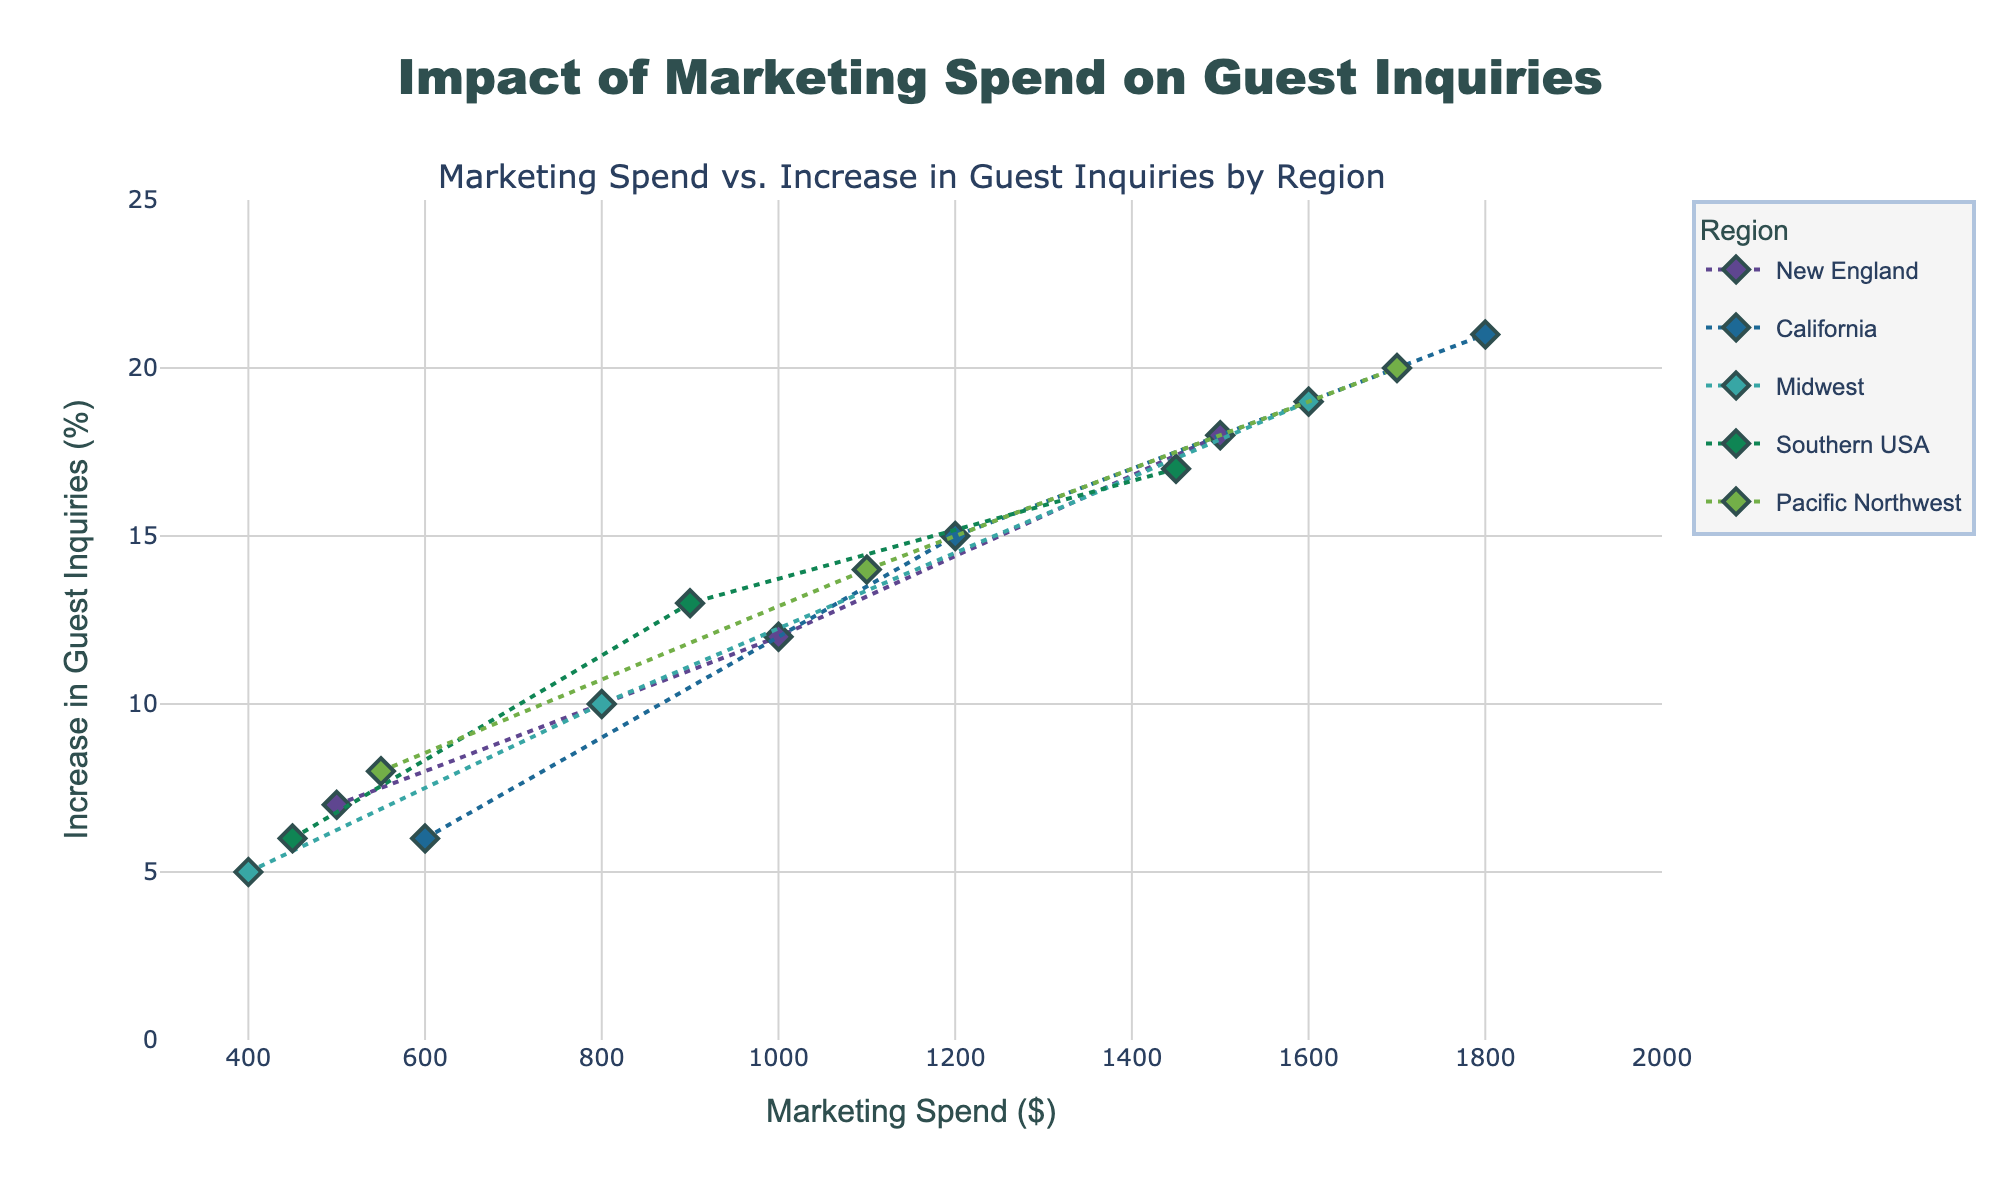How does marketing spend affect guest inquiries in the California region? By observing the scatter plot for the California region, we see that as the marketing spend increases from $600 to $1800, guest inquiries increase from 6% to 21%. There is a positive correlation between marketing spend and guest inquiries.
Answer: Positive correlation Which region shows the highest increase in guest inquiries for the same marketing spend of $1500? By comparing the data points closest to the $1500 marketing spend mark in each region, the Pacific Northwest has the highest increase in guest inquiries at around 20%.
Answer: Pacific Northwest What is the trend of marketing spend vs. increase in guest inquiries for the Midwest region? In the Midwest region, as marketing spend increases from $400 to $1600, guest inquiries increase from 5% to 19%, indicating a positive correlation.
Answer: Positive correlation Is there any region where increase in guest inquiries is less than 10% for the highest marketing spend? By examining the data points, all regions show more than a 10% increase in guest inquiries for their highest marketing spend.
Answer: No Compare the average increase in guest inquiries for New England and Midwest regions. To find the average increase, sum the respective % increases and divide by the number of data points. For New England: (7 + 12+ 18)/3 = 12.33%. For Midwest: (5 + 10 + 19)/3 = 11.33%. New England has a slightly higher average.
Answer: New England Which region has the steepest increase in guest inquiries as a function of marketing spend? By visual inspection, California appears to have the steepest increase since its slope is more pronounced than the other regions.
Answer: California Does the Southern USA region have a linear trend between marketing spend and guest inquiries? By observing the plot, the increase in guest inquiries is relatively consistent for the Southern USA, suggesting a linear trend.
Answer: Yes What is the range of increase in guest inquiries for the Pacific Northwest region based on the visual data? The increase in guest inquiries for the Pacific Northwest ranges from 8% to 20% as seen from the corresponding data points in the plot.
Answer: 8% to 20% 